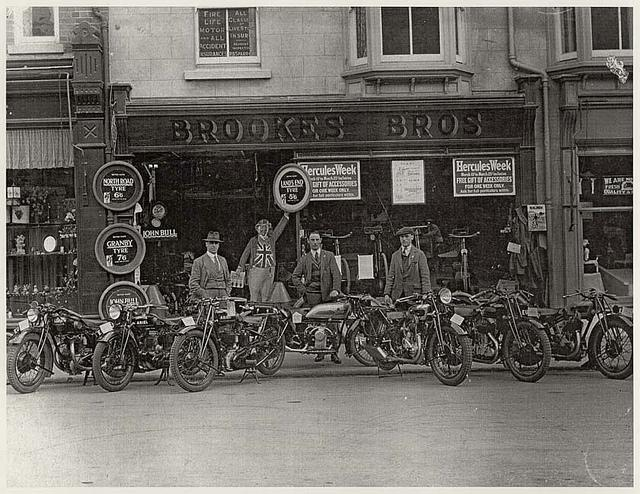What countries flag can be seen on the man's shirt? Please explain your reasoning. united kingdom. United kingdom is on his shirt. 